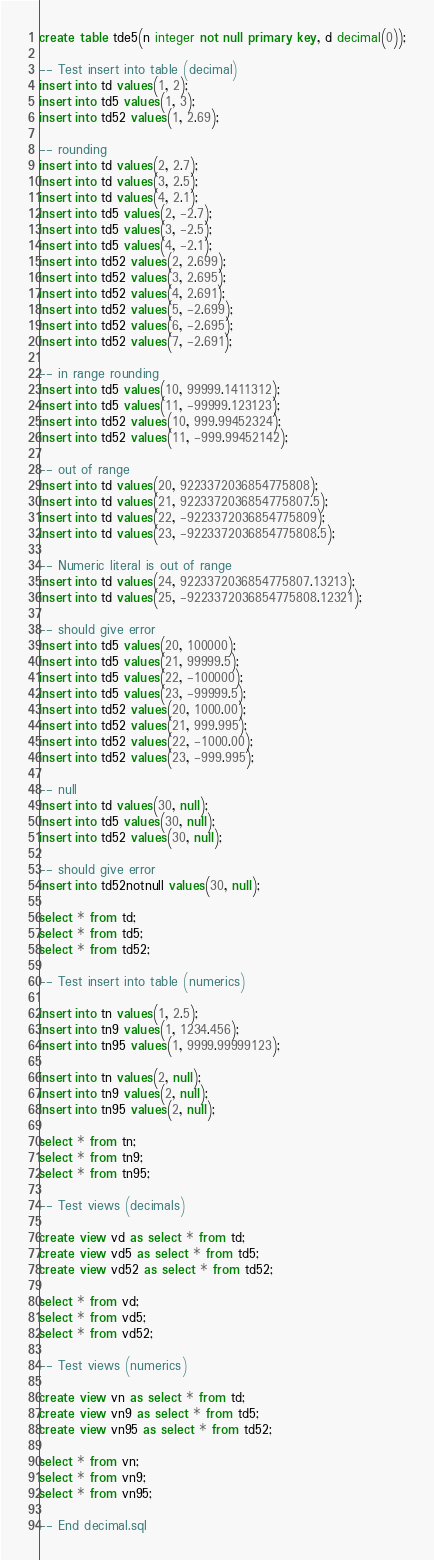<code> <loc_0><loc_0><loc_500><loc_500><_SQL_>create table tde5(n integer not null primary key, d decimal(0));

-- Test insert into table (decimal)
insert into td values(1, 2);
insert into td5 values(1, 3);
insert into td52 values(1, 2.69);

-- rounding
insert into td values(2, 2.7);
insert into td values(3, 2.5);
insert into td values(4, 2.1);
insert into td5 values(2, -2.7);
insert into td5 values(3, -2.5);
insert into td5 values(4, -2.1);
insert into td52 values(2, 2.699);
insert into td52 values(3, 2.695);
insert into td52 values(4, 2.691);
insert into td52 values(5, -2.699);
insert into td52 values(6, -2.695);
insert into td52 values(7, -2.691);

-- in range rounding
insert into td5 values(10, 99999.1411312);
insert into td5 values(11, -99999.123123); 
insert into td52 values(10, 999.99452324);
insert into td52 values(11, -999.99452142); 

-- out of range
insert into td values(20, 9223372036854775808);
insert into td values(21, 9223372036854775807.5);
insert into td values(22, -9223372036854775809);
insert into td values(23, -9223372036854775808.5);

-- Numeric literal is out of range
insert into td values(24, 9223372036854775807.13213);
insert into td values(25, -9223372036854775808.12321);

-- should give error
insert into td5 values(20, 100000);
insert into td5 values(21, 99999.5); 
insert into td5 values(22, -100000);
insert into td5 values(23, -99999.5); 
insert into td52 values(20, 1000.00);
insert into td52 values(21, 999.995);
insert into td52 values(22, -1000.00);
insert into td52 values(23, -999.995); 

-- null
insert into td values(30, null);
insert into td5 values(30, null);
insert into td52 values(30, null);

-- should give error
insert into td52notnull values(30, null);

select * from td;
select * from td5;
select * from td52;

-- Test insert into table (numerics)

insert into tn values(1, 2.5);
insert into tn9 values(1, 1234.456);
insert into tn95 values(1, 9999.99999123);

insert into tn values(2, null);
insert into tn9 values(2, null);
insert into tn95 values(2, null);

select * from tn;
select * from tn9;
select * from tn95;

-- Test views (decimals)

create view vd as select * from td;
create view vd5 as select * from td5;
create view vd52 as select * from td52;

select * from vd;
select * from vd5;
select * from vd52;

-- Test views (numerics)

create view vn as select * from td;
create view vn9 as select * from td5;
create view vn95 as select * from td52;

select * from vn;
select * from vn9;
select * from vn95;

-- End decimal.sql
</code> 